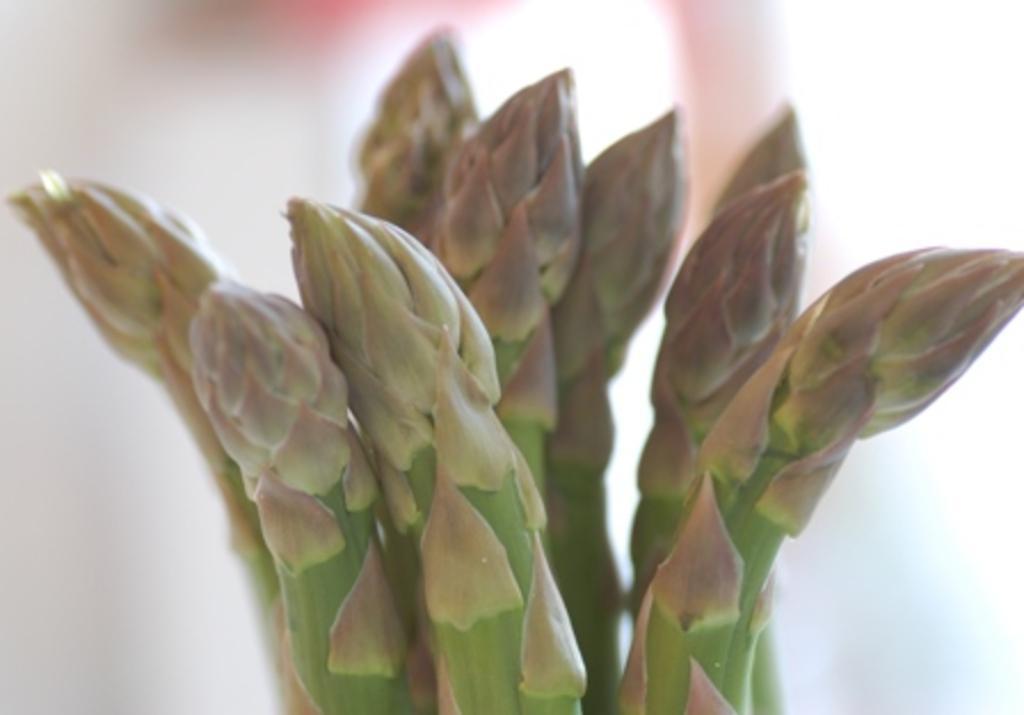How would you summarize this image in a sentence or two? In this image there is a cactus in the foreground. The background is blurry. 